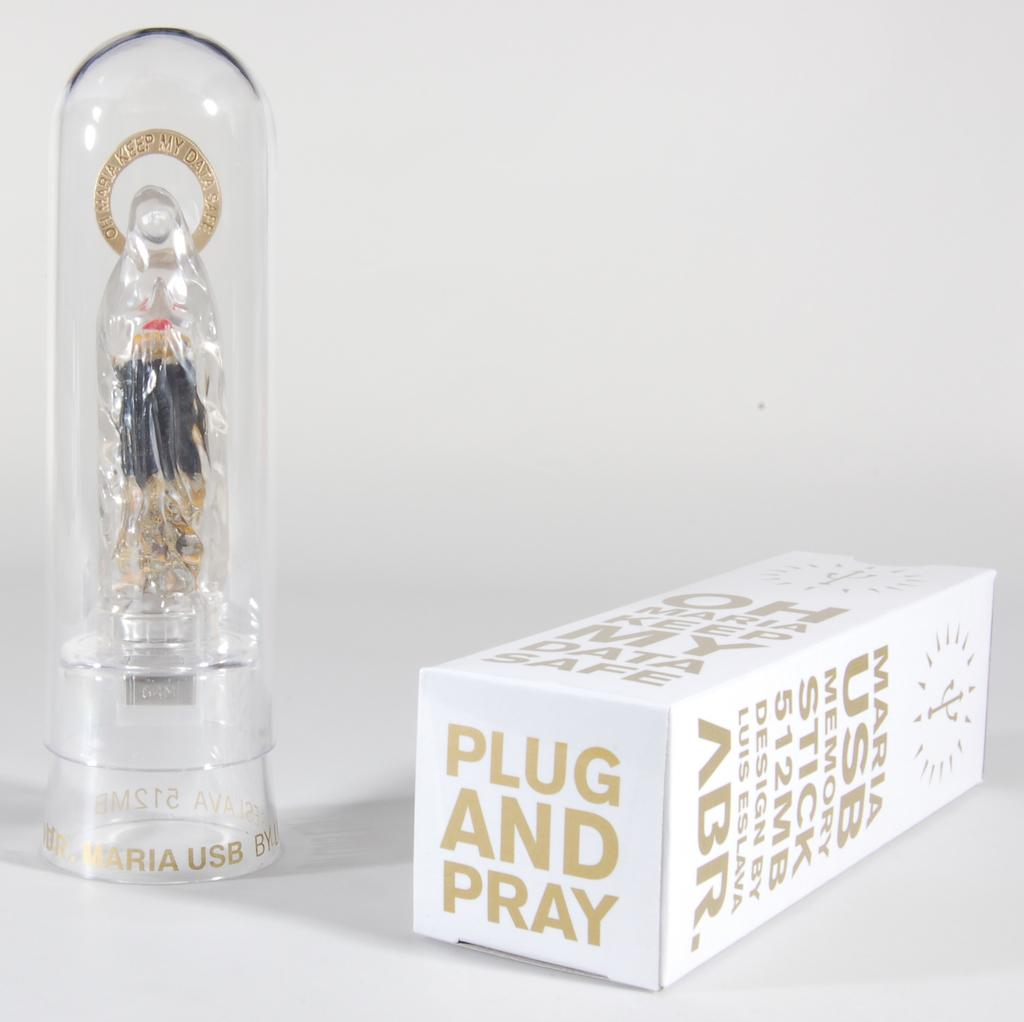Provide a one-sentence caption for the provided image. White box of Maria USBmemory stick 512MB plug and pray. 